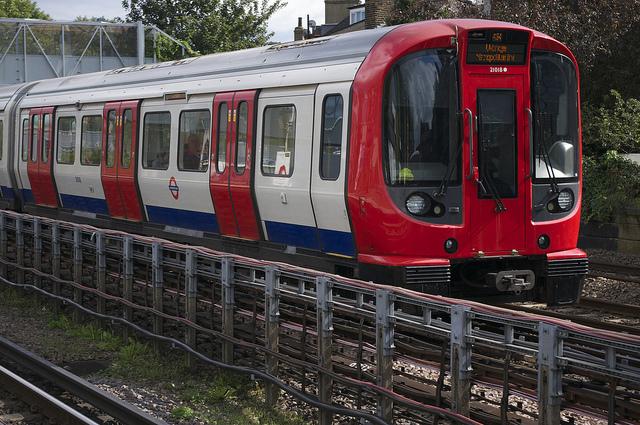Is the train moving?
Concise answer only. Yes. Is the grass thick?
Short answer required. No. What color is the train?
Answer briefly. Red white blue. 